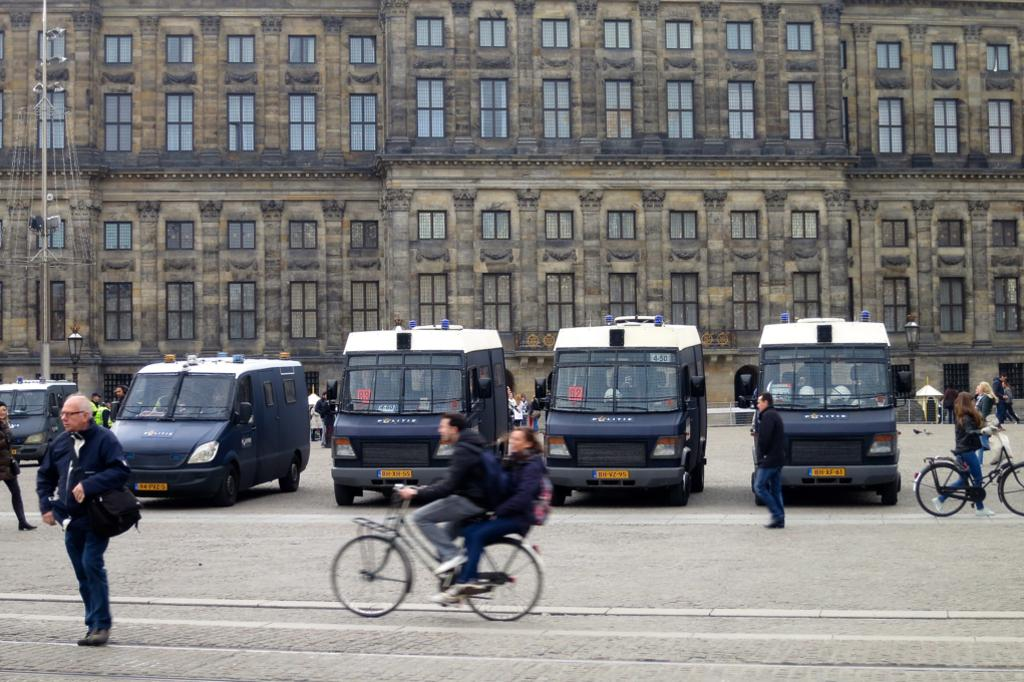What are the people in the image doing? There are persons standing on the road and persons riding bicycles in the image. What types of vehicles are present in the image? Motor vehicles are present in the image. What structures can be seen in the background? There are buildings visible in the image. What type of street furniture is present? Street poles and street lights are present in the image. What type of accessory is visible? Parasols are visible in the image. What architectural features can be seen on the buildings? Windows are present on the buildings. What type of decorative feature is in the image? A fountain is in the image. How many earthquakes can be seen in the image? There are no earthquakes present in the image. What type of window is visible on the person's leg in the image? There are no windows or legs visible on any person in the image. 